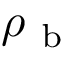Convert formula to latex. <formula><loc_0><loc_0><loc_500><loc_500>\rho _ { b }</formula> 